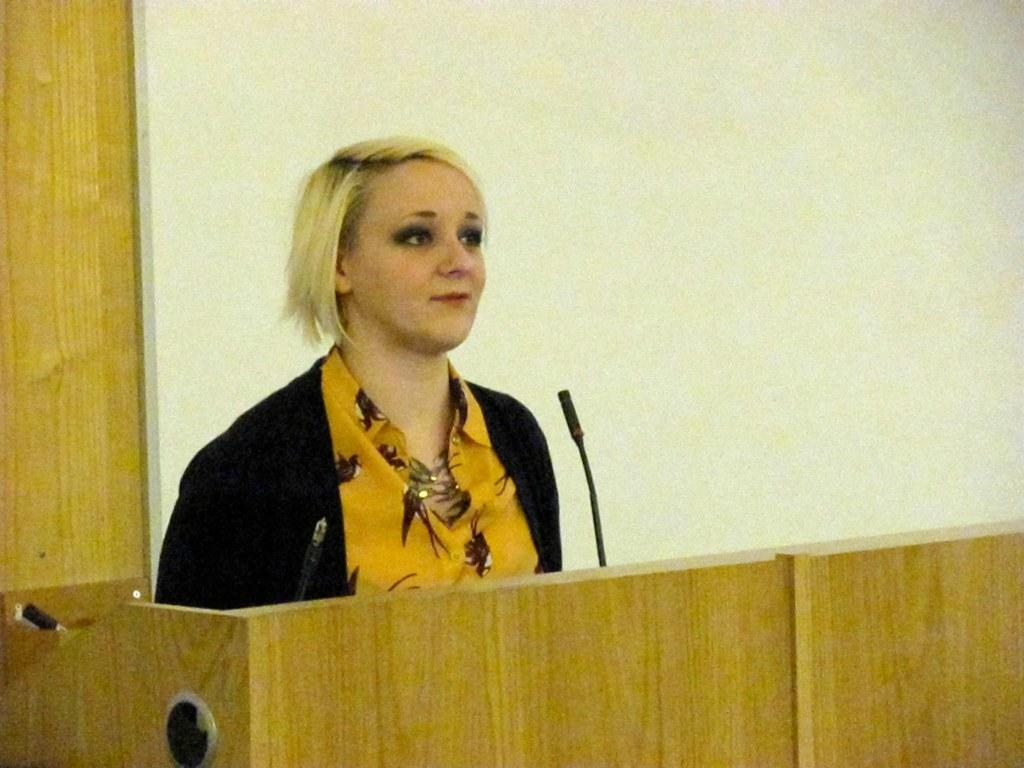Who is the main subject in the image? There is a woman in the image. What is the woman doing in the image? The woman is standing near a podium. What object is in front of the woman? There is a microphone in front of the woman. What can be seen behind the woman? There is a wall behind the woman. What is the color of the wall? The wall is white in color. What type of lettuce is being used as a prop in the image? There is no lettuce present in the image. How many tomatoes are on the podium in the image? There are no tomatoes present in the image. 